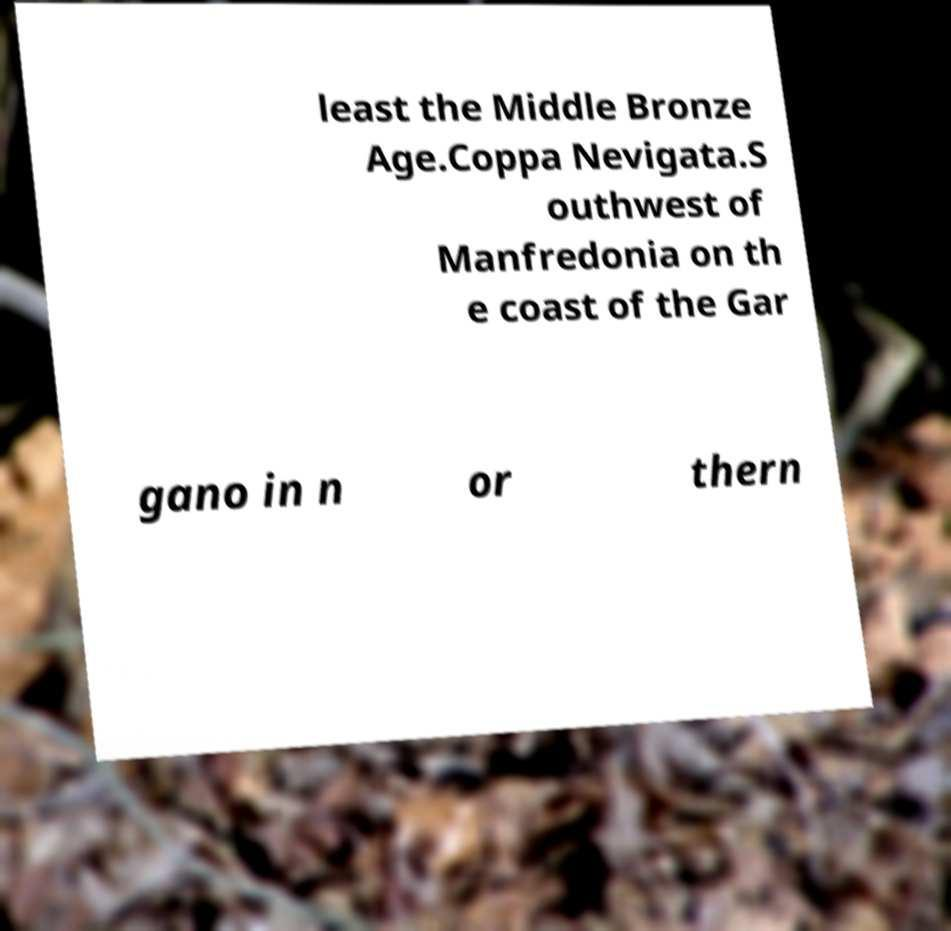Could you assist in decoding the text presented in this image and type it out clearly? least the Middle Bronze Age.Coppa Nevigata.S outhwest of Manfredonia on th e coast of the Gar gano in n or thern 